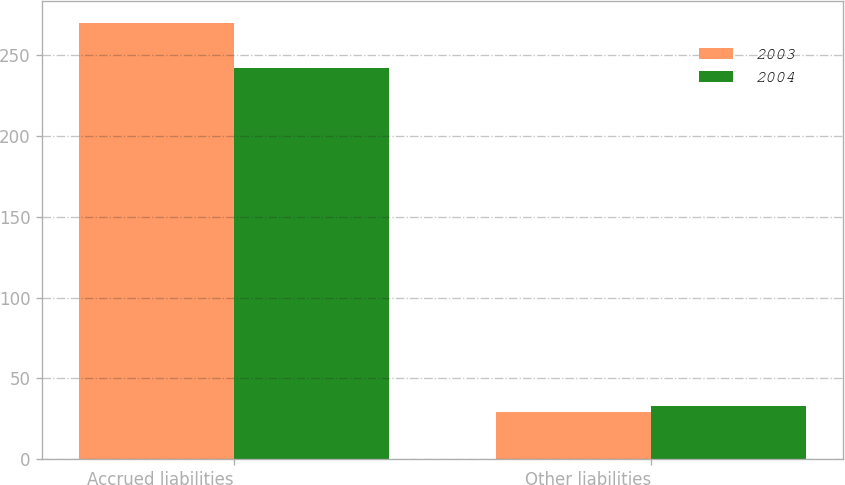Convert chart to OTSL. <chart><loc_0><loc_0><loc_500><loc_500><stacked_bar_chart><ecel><fcel>Accrued liabilities<fcel>Other liabilities<nl><fcel>2003<fcel>270<fcel>29<nl><fcel>2004<fcel>242<fcel>33<nl></chart> 